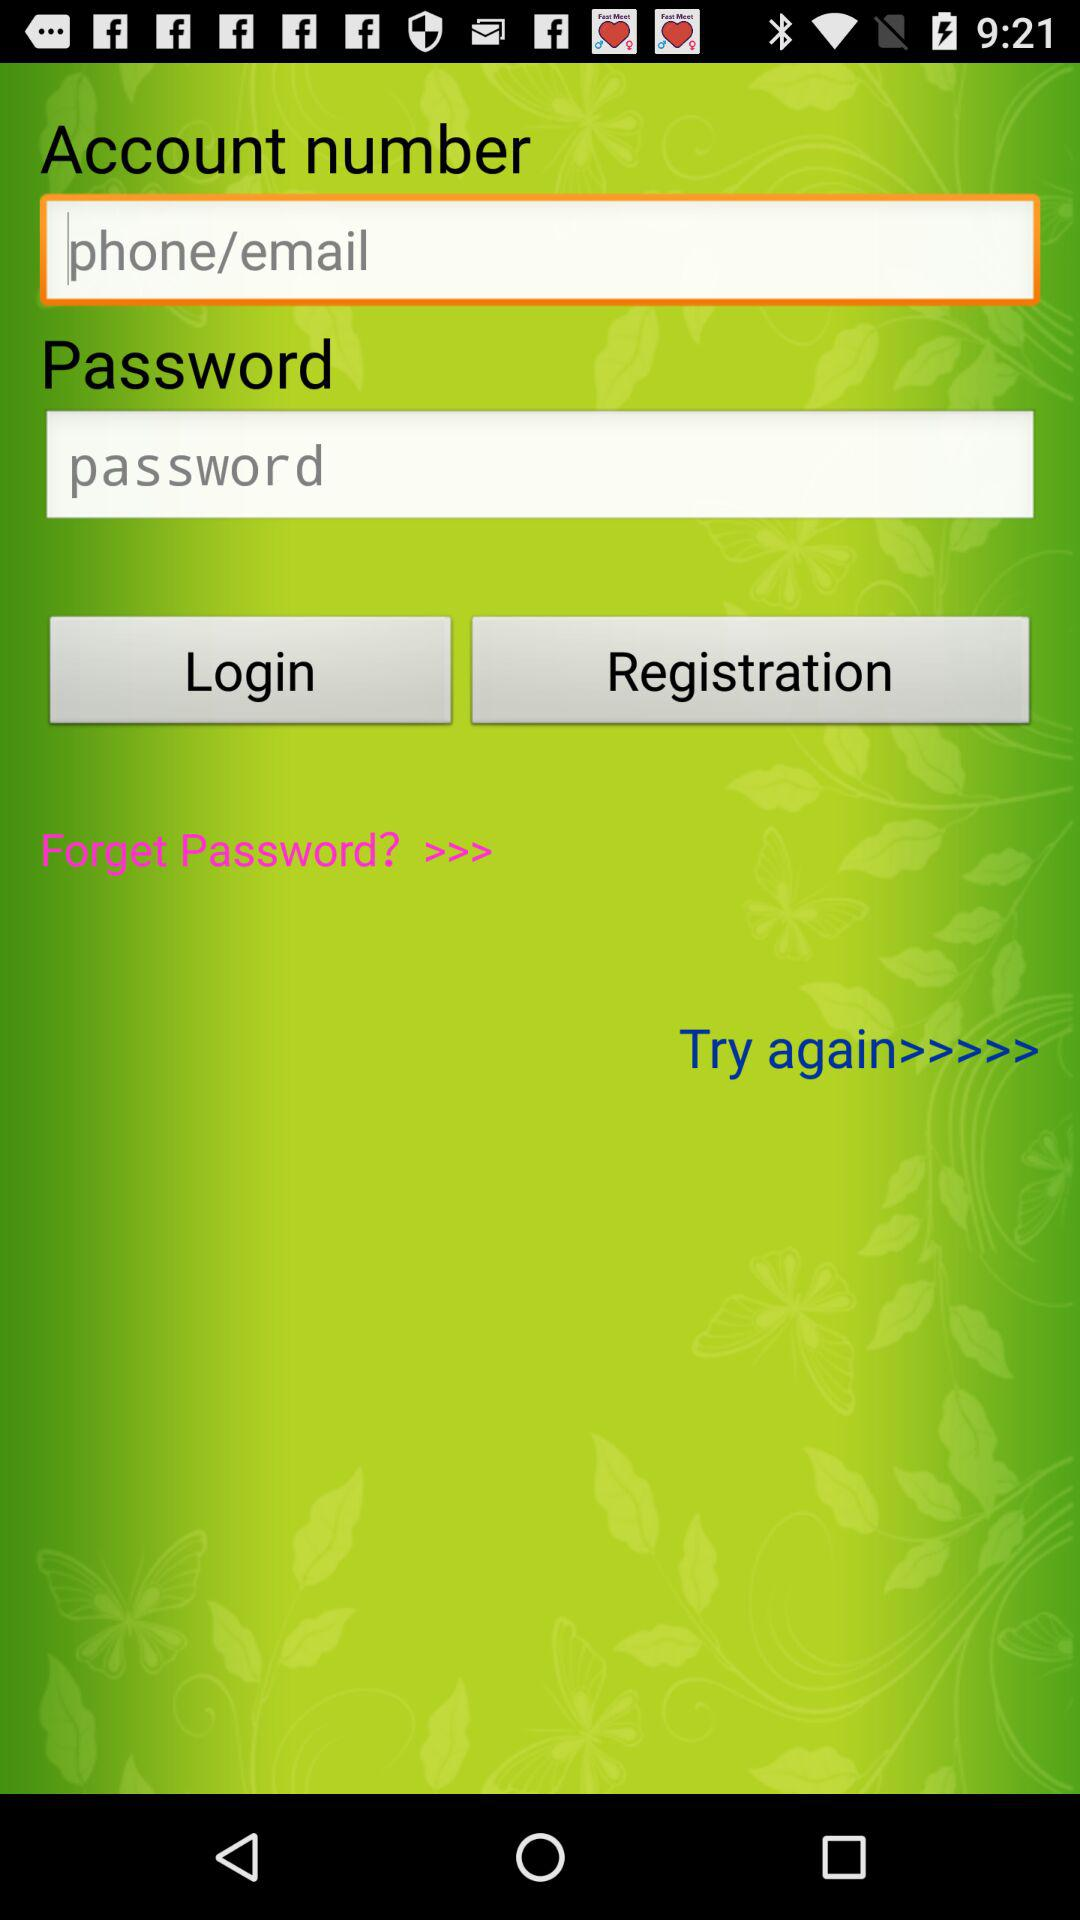How many text inputs are required to login?
Answer the question using a single word or phrase. 2 